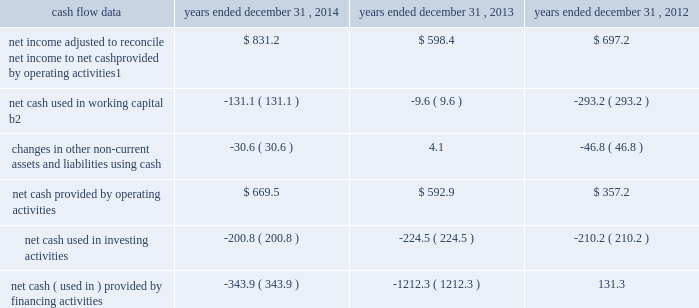Management 2019s discussion and analysis of financial condition and results of operations 2013 ( continued ) ( amounts in millions , except per share amounts ) corporate and other expenses increased slightly during 2013 by $ 3.5 to $ 140.8 compared to 2012 , primarily due to an increase in salaries and related expenses , mainly attributable to higher base salaries , benefits and temporary help , partially offset by lower severance expenses and a decrease in office and general expenses .
Liquidity and capital resources cash flow overview the tables summarize key financial data relating to our liquidity , capital resources and uses of capital. .
1 reflects net income adjusted primarily for depreciation and amortization of fixed assets and intangible assets , amortization of restricted stock and other non-cash compensation , non-cash ( gain ) loss related to early extinguishment of debt , and deferred income taxes .
2 reflects changes in accounts receivable , expenditures billable to clients , other current assets , accounts payable and accrued liabilities .
Operating activities net cash provided by operating activities during 2014 was $ 669.5 , which was an improvement of $ 76.6 as compared to 2013 , primarily as a result of an increase in net income , offset by an increase in working capital usage of $ 121.5 .
Due to the seasonality of our business , we typically generate cash from working capital in the second half of a year and use cash from working capital in the first half of a year , with the largest impacts in the first and fourth quarters .
Our net working capital usage in 2014 was impacted by our media businesses .
Net cash provided by operating activities during 2013 was $ 592.9 , which was an increase of $ 235.7 as compared to 2012 , primarily as a result of an improvement in working capital usage of $ 283.6 , offset by a decrease in net income .
The improvement in working capital in 2013 was impacted by our media businesses and an ongoing focus on working capital management at our agencies .
The timing of media buying on behalf of our clients affects our working capital and operating cash flow .
In most of our businesses , our agencies enter into commitments to pay production and media costs on behalf of clients .
To the extent possible we pay production and media charges after we have received funds from our clients .
The amounts involved substantially exceed our revenues and primarily affect the level of accounts receivable , expenditures billable to clients , accounts payable and accrued liabilities .
Our assets include both cash received and accounts receivable from clients for these pass-through arrangements , while our liabilities include amounts owed on behalf of clients to media and production suppliers .
Our accrued liabilities are also affected by the timing of certain other payments .
For example , while annual cash incentive awards are accrued throughout the year , they are generally paid during the first quarter of the subsequent year .
Investing activities net cash used in investing activities during 2014 primarily related to payments for capital expenditures and acquisitions .
Capital expenditures of $ 148.7 related primarily to computer hardware and software and leasehold improvements .
We made payments of $ 67.8 related to acquisitions completed during 2014 , net of cash acquired. .
What is the net change in cash for the 2014? 
Computations: ((669.5 + -200.8) + -343.9)
Answer: 124.8. 